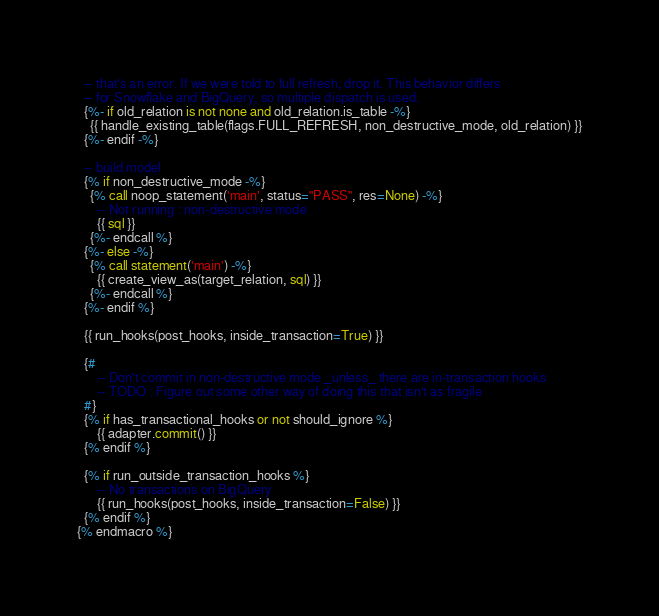Convert code to text. <code><loc_0><loc_0><loc_500><loc_500><_SQL_>  -- that's an error. If we were told to full refresh, drop it. This behavior differs
  -- for Snowflake and BigQuery, so multiple dispatch is used.
  {%- if old_relation is not none and old_relation.is_table -%}
    {{ handle_existing_table(flags.FULL_REFRESH, non_destructive_mode, old_relation) }}
  {%- endif -%}

  -- build model
  {% if non_destructive_mode -%}
    {% call noop_statement('main', status="PASS", res=None) -%}
      -- Not running : non-destructive mode
      {{ sql }}
    {%- endcall %}
  {%- else -%}
    {% call statement('main') -%}
      {{ create_view_as(target_relation, sql) }}
    {%- endcall %}
  {%- endif %}

  {{ run_hooks(post_hooks, inside_transaction=True) }}

  {#
      -- Don't commit in non-destructive mode _unless_ there are in-transaction hooks
      -- TODO : Figure out some other way of doing this that isn't as fragile
  #}
  {% if has_transactional_hooks or not should_ignore %}
      {{ adapter.commit() }}
  {% endif %}

  {% if run_outside_transaction_hooks %}
      -- No transactions on BigQuery
      {{ run_hooks(post_hooks, inside_transaction=False) }}
  {% endif %}
{% endmacro %}
</code> 